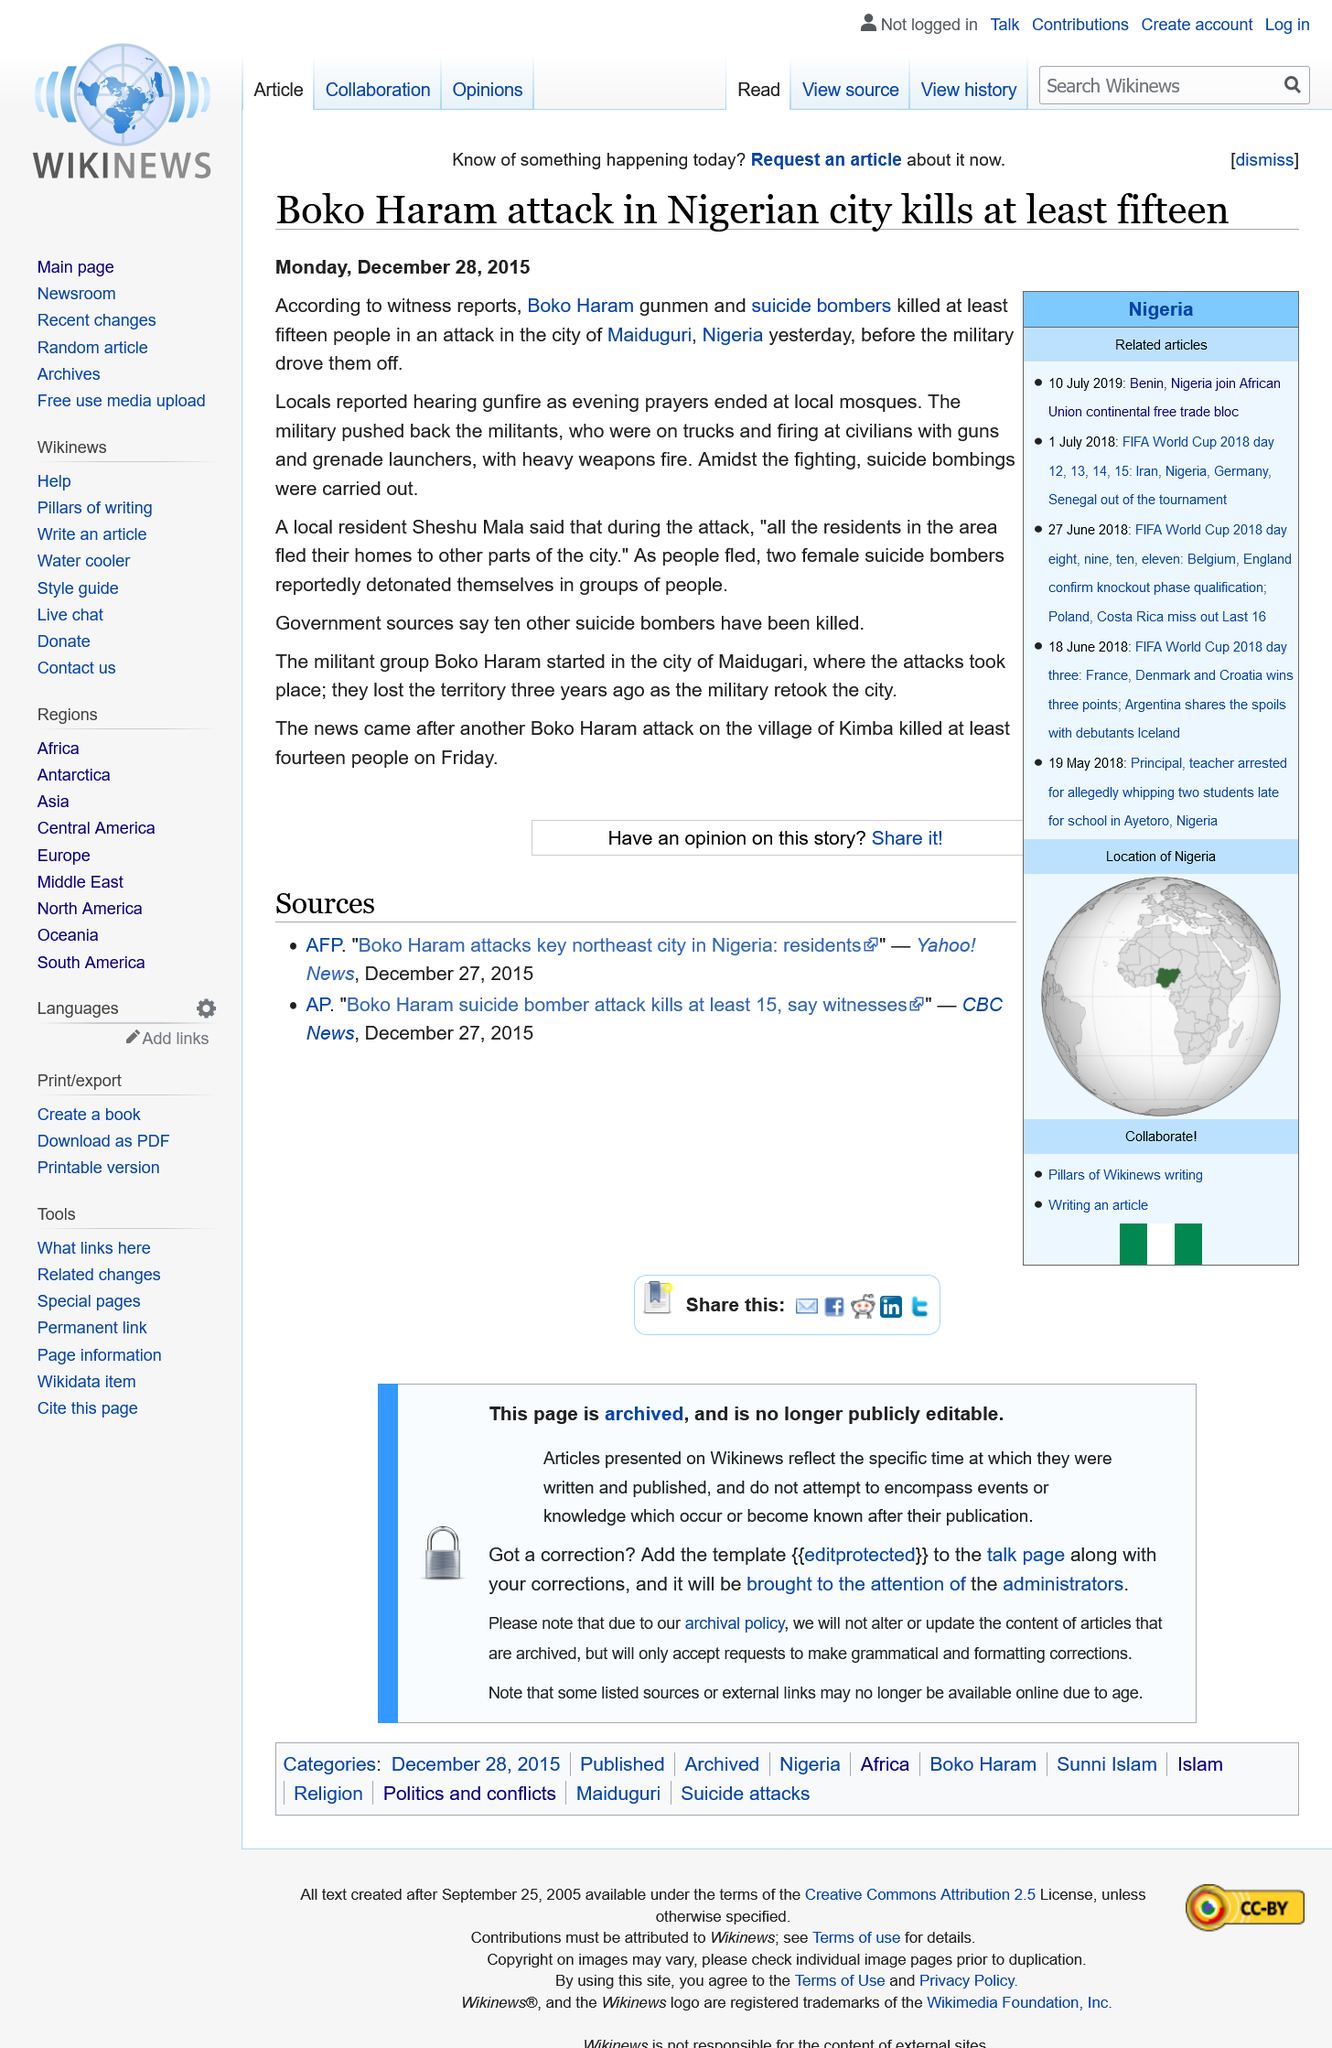Point out several critical features in this image. Boko Haram carried out the attack in Maiduguri on December 27th, 2015. Twelve suicide bombers were reportedly killed in the attack in Maiduguri on December 27th 2015. The city of Maiduguri is located in the country of Nigeria. 